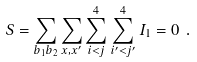Convert formula to latex. <formula><loc_0><loc_0><loc_500><loc_500>S = \sum _ { b _ { 1 } b _ { 2 } } \sum _ { x , x ^ { \prime } } \sum _ { i < j } ^ { 4 } \sum _ { i ^ { \prime } < j ^ { \prime } } ^ { 4 } I _ { 1 } = 0 \ .</formula> 